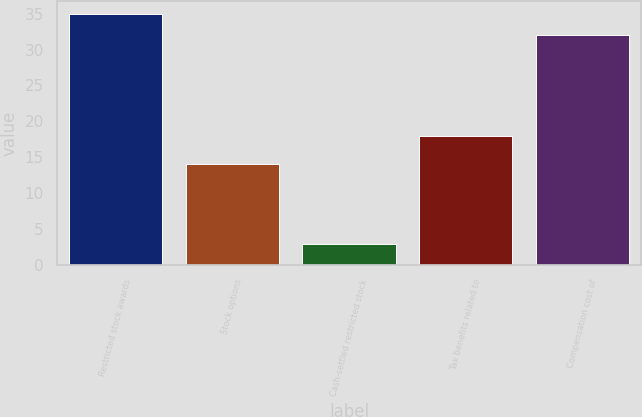<chart> <loc_0><loc_0><loc_500><loc_500><bar_chart><fcel>Restricted stock awards<fcel>Stock options<fcel>Cash-settled restricted stock<fcel>Tax benefits related to<fcel>Compensation cost of<nl><fcel>35<fcel>14<fcel>3<fcel>18<fcel>32<nl></chart> 